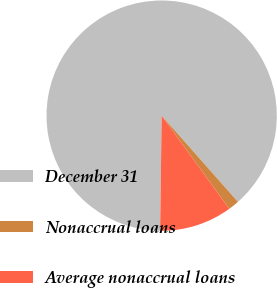Convert chart. <chart><loc_0><loc_0><loc_500><loc_500><pie_chart><fcel>December 31<fcel>Nonaccrual loans<fcel>Average nonaccrual loans<nl><fcel>88.26%<fcel>1.53%<fcel>10.21%<nl></chart> 